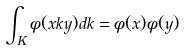<formula> <loc_0><loc_0><loc_500><loc_500>\int _ { K } \phi ( x k y ) d k = \phi ( x ) \phi ( y )</formula> 